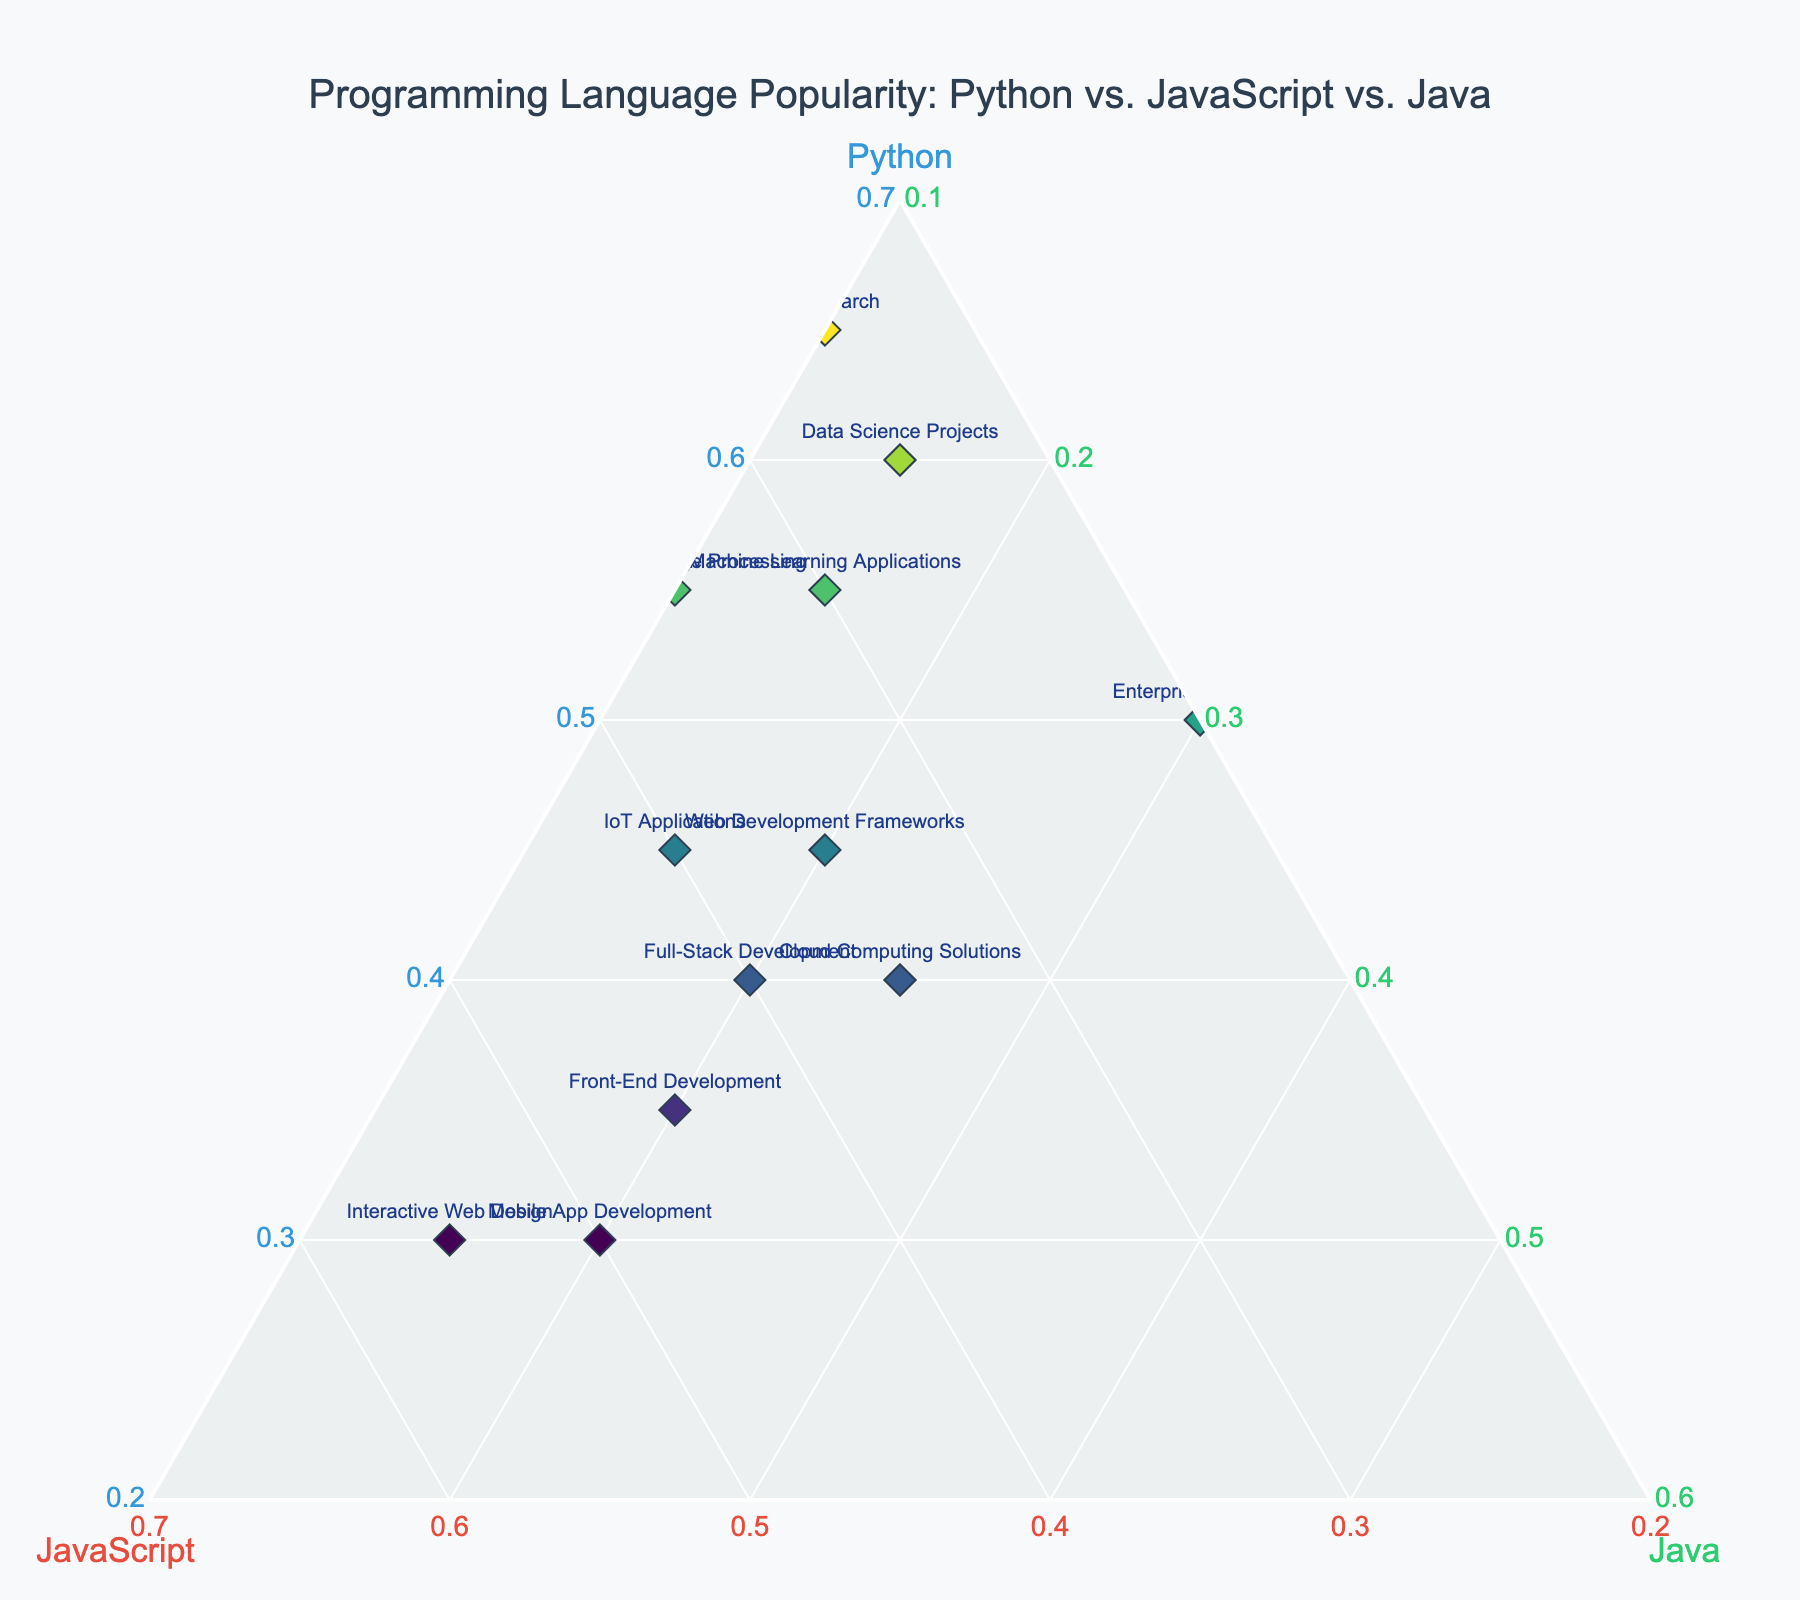What's the most popular programming language for AI Research? Find the data point labeled "AI Research" on the ternary plot. Look at the values for Python, JavaScript, and Java. Python has the highest value of the three.
Answer: Python How many development categories have Python as the dominant language? Identify data points where the Python percentage is the highest among the three languages. Count them. Relevant labels are: Machine Learning Applications, AI Research, Data Science Projects, Natural Language Processing, and Web Development Frameworks.
Answer: 5 Which type of development has the least popularity for Java? Find the data points and compare the Java values. The label with the lowest Java value is "AI Research" (10%).
Answer: AI Research What percentage of JavaScript is used in Front-End Development compared to Mobile App Development? Locate both data points. Front-End Development has 45% for JavaScript, and Mobile App Development has 50%. The difference is calculated as 50% - 45%.
Answer: 5% Is Full-Stack Development more balanced in language popularity compared to Interactive Web Design? Compare the three percentages for both data points. Full-Stack Development has Python (40%), JavaScript (40%), Java (20%). Interactive Web Design has more skewed values: JavaScript (55%), Python (30%), and Java (15%). Full-Stack is more balanced.
Answer: Yes Identify the development category most balanced across all three languages. Find data points where percentages of Python, JavaScript, and Java are close to each other. Full-Stack Development (Python: 40%, JavaScript: 40%, Java: 20%) is the most balanced.
Answer: Full-Stack Development If you combine the percentages of Python for Natural Language Processing and IoT Applications, what is the result? Locate the percentages for Natural Language Processing (55%) and IoT Applications (45%). Add these values together. 55% + 45% = 100%.
Answer: 100% Which language has the highest use in Cloud Computing Solutions? Look at the data point labeled "Cloud Computing Solutions." Compare the values for Python (40%), JavaScript (35%), and Java (25%). Python has the highest percentage.
Answer: Python What is the combined percentage of Python and JavaScript for Data Science Projects? Locate the percentages for Python (60%) and JavaScript (25%) in Data Science Projects. Add these together. 60% + 25% = 85%.
Answer: 85% Which development category uses JavaScript significantly more than Java? Compare the JavaScript values with Java values. The significant difference is seen in categories like Interactive Web Design (JavaScript 55%, Java 15%).
Answer: Interactive Web Design 